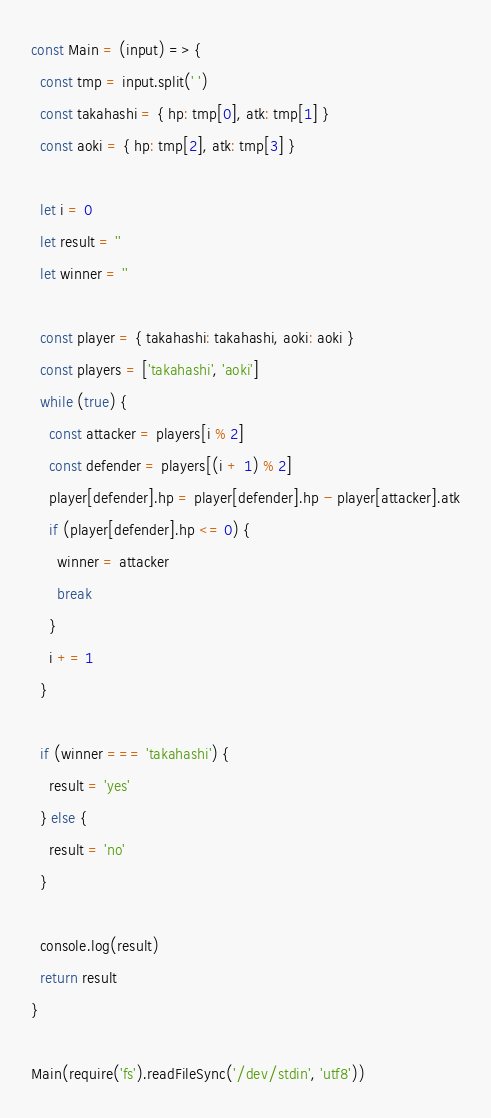<code> <loc_0><loc_0><loc_500><loc_500><_JavaScript_>const Main = (input) => {
  const tmp = input.split(' ')
  const takahashi = { hp: tmp[0], atk: tmp[1] }
  const aoki = { hp: tmp[2], atk: tmp[3] }

  let i = 0
  let result = ''
  let winner = ''

  const player = { takahashi: takahashi, aoki: aoki }
  const players = ['takahashi', 'aoki']
  while (true) {
    const attacker = players[i % 2]
    const defender = players[(i + 1) % 2]
    player[defender].hp = player[defender].hp - player[attacker].atk
    if (player[defender].hp <= 0) {
      winner = attacker
      break
    }
    i += 1
  }

  if (winner === 'takahashi') {
    result = 'yes'
  } else {
    result = 'no'
  }

  console.log(result)
  return result
}

Main(require('fs').readFileSync('/dev/stdin', 'utf8'))
</code> 